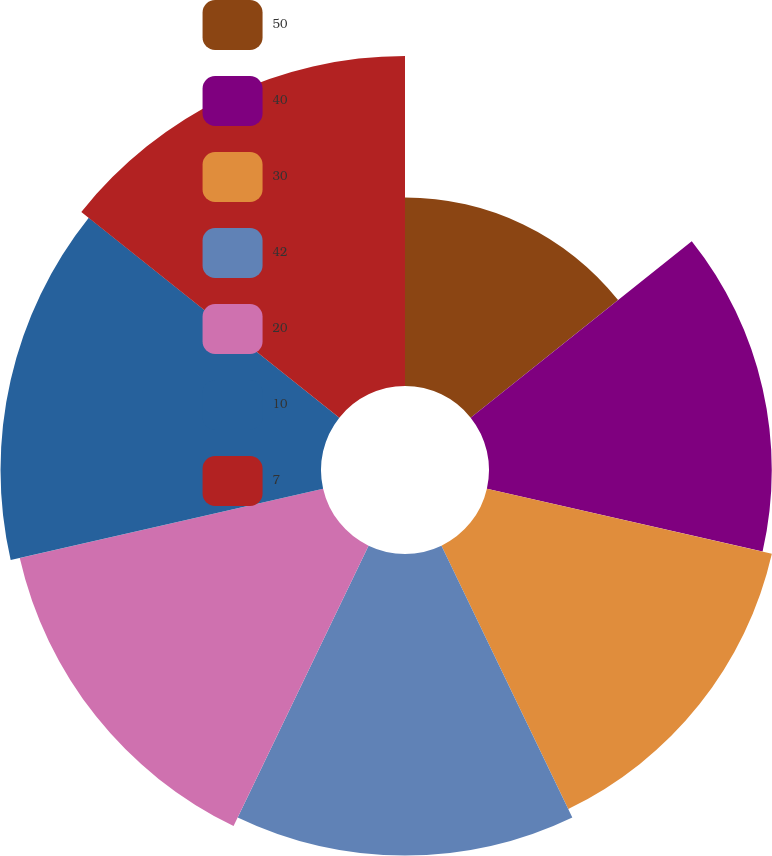Convert chart to OTSL. <chart><loc_0><loc_0><loc_500><loc_500><pie_chart><fcel>50<fcel>40<fcel>30<fcel>42<fcel>20<fcel>10<fcel>7<nl><fcel>9.3%<fcel>13.95%<fcel>14.42%<fcel>14.88%<fcel>15.35%<fcel>15.81%<fcel>16.28%<nl></chart> 